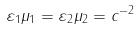Convert formula to latex. <formula><loc_0><loc_0><loc_500><loc_500>\varepsilon _ { 1 } \mu _ { 1 } = \varepsilon _ { 2 } \mu _ { 2 } = c ^ { - 2 }</formula> 